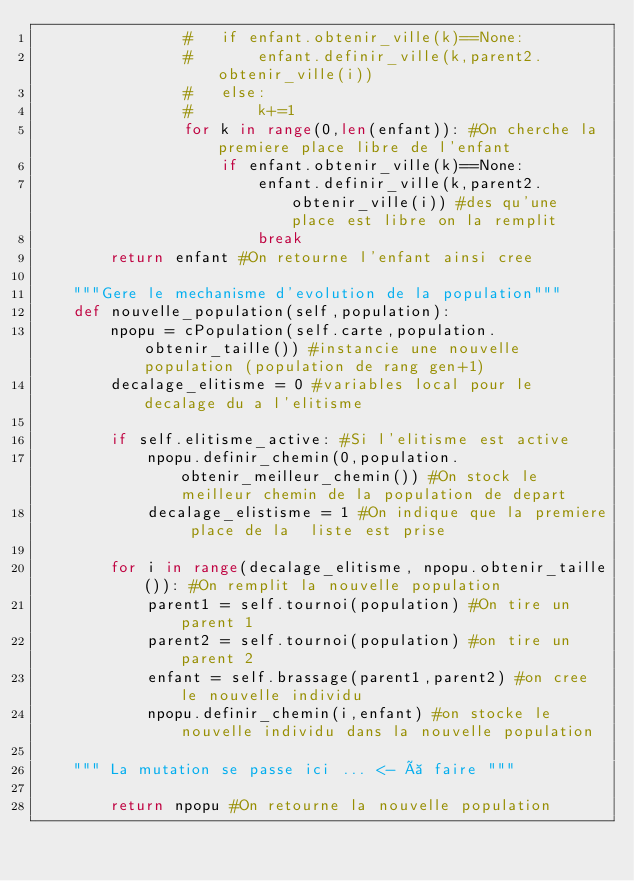Convert code to text. <code><loc_0><loc_0><loc_500><loc_500><_Python_>				#	if enfant.obtenir_ville(k)==None:
				#		enfant.definir_ville(k,parent2.obtenir_ville(i))
				#	else:
				#		k+=1
				for k in range(0,len(enfant)): #On cherche la premiere place libre de l'enfant
					if enfant.obtenir_ville(k)==None:
						enfant.definir_ville(k,parent2.obtenir_ville(i)) #des qu'une place est libre on la remplit
						break		
		return enfant #On retourne l'enfant ainsi cree

	"""Gere le mechanisme d'evolution de la population"""
	def nouvelle_population(self,population):
		npopu = cPopulation(self.carte,population.obtenir_taille()) #instancie une nouvelle population (population de rang gen+1)
		decalage_elitisme = 0 #variables local pour le decalage du a l'elitisme

		if self.elitisme_active: #Si l'elitisme est active
			npopu.definir_chemin(0,population.obtenir_meilleur_chemin()) #On stock le meilleur chemin de la population de depart
			decalage_elistisme = 1 #On indique que la premiere place de la  liste est prise

		for i in range(decalage_elitisme, npopu.obtenir_taille()): #On remplit la nouvelle population
			parent1 = self.tournoi(population) #On tire un parent 1
			parent2 = self.tournoi(population) #on tire un parent 2
			enfant = self.brassage(parent1,parent2) #on cree le nouvelle individu
			npopu.definir_chemin(i,enfant) #on stocke le nouvelle individu dans la nouvelle population

	""" La mutation se passe ici ... <- à faire """

		return npopu #On retourne la nouvelle population
</code> 